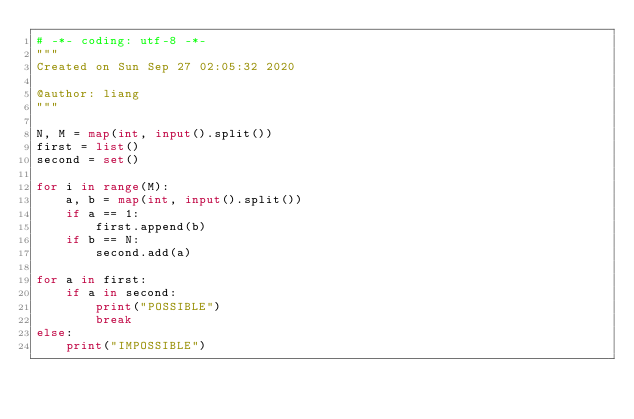<code> <loc_0><loc_0><loc_500><loc_500><_Python_># -*- coding: utf-8 -*-
"""
Created on Sun Sep 27 02:05:32 2020

@author: liang
"""

N, M = map(int, input().split())
first = list()
second = set()

for i in range(M):
    a, b = map(int, input().split())
    if a == 1:
        first.append(b)
    if b == N:
        second.add(a)
        
for a in first:
    if a in second:
        print("POSSIBLE")
        break
else:
    print("IMPOSSIBLE")</code> 